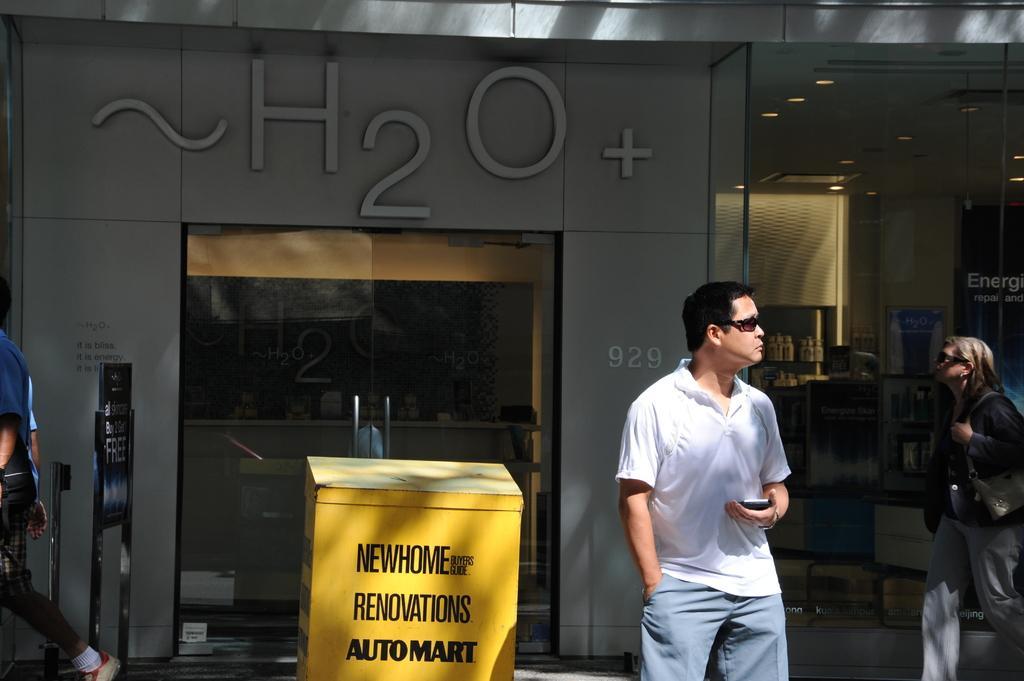How would you summarize this image in a sentence or two? In front of the image there is a person standing by holding a mobile phone in his hand, behind the person there is an object with some text. Behind the object there are a few people walking on the pavement, behind them there are shops with name boards on it and glass doors. In front of the shops there are display boards. In the shops there are some objects. 